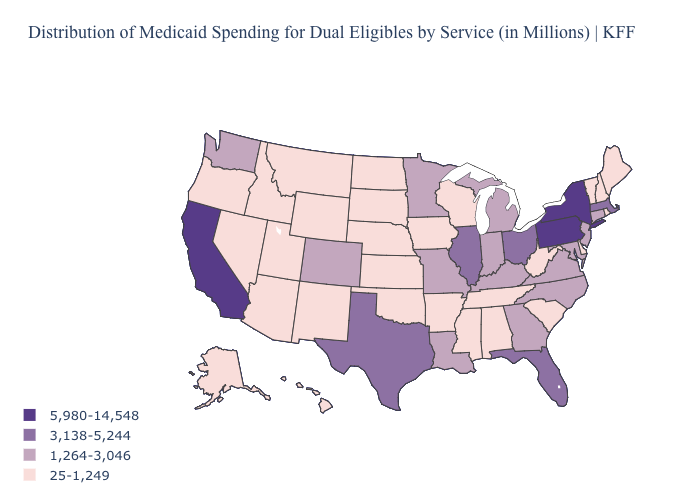Does Arizona have the highest value in the USA?
Give a very brief answer. No. Which states hav the highest value in the West?
Quick response, please. California. What is the highest value in states that border Vermont?
Quick response, please. 5,980-14,548. What is the value of South Dakota?
Quick response, please. 25-1,249. What is the lowest value in the USA?
Be succinct. 25-1,249. How many symbols are there in the legend?
Write a very short answer. 4. What is the value of Oklahoma?
Write a very short answer. 25-1,249. What is the lowest value in the West?
Concise answer only. 25-1,249. What is the value of California?
Keep it brief. 5,980-14,548. Does the first symbol in the legend represent the smallest category?
Answer briefly. No. Does New Mexico have a lower value than Hawaii?
Answer briefly. No. Does the first symbol in the legend represent the smallest category?
Give a very brief answer. No. Which states have the lowest value in the MidWest?
Give a very brief answer. Iowa, Kansas, Nebraska, North Dakota, South Dakota, Wisconsin. Among the states that border New Jersey , which have the highest value?
Quick response, please. New York, Pennsylvania. Among the states that border Utah , does New Mexico have the lowest value?
Keep it brief. Yes. 